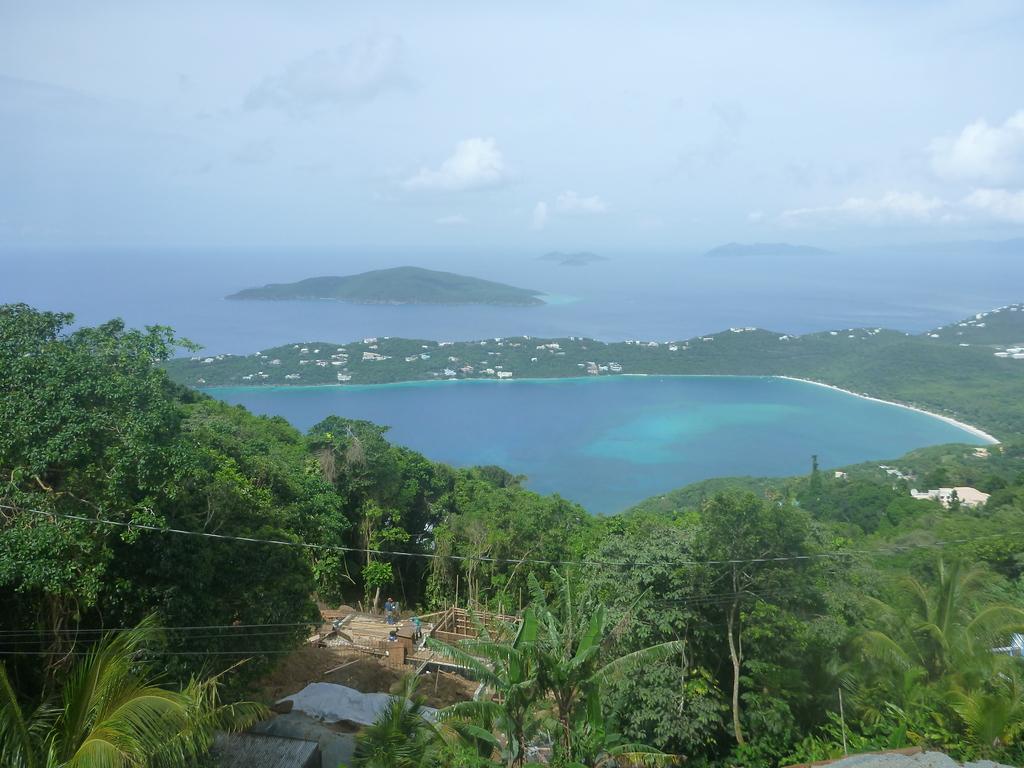Could you give a brief overview of what you see in this image? In this picture I can see at the bottom there are trees, in the middle there is water. At the top there is the sky. 